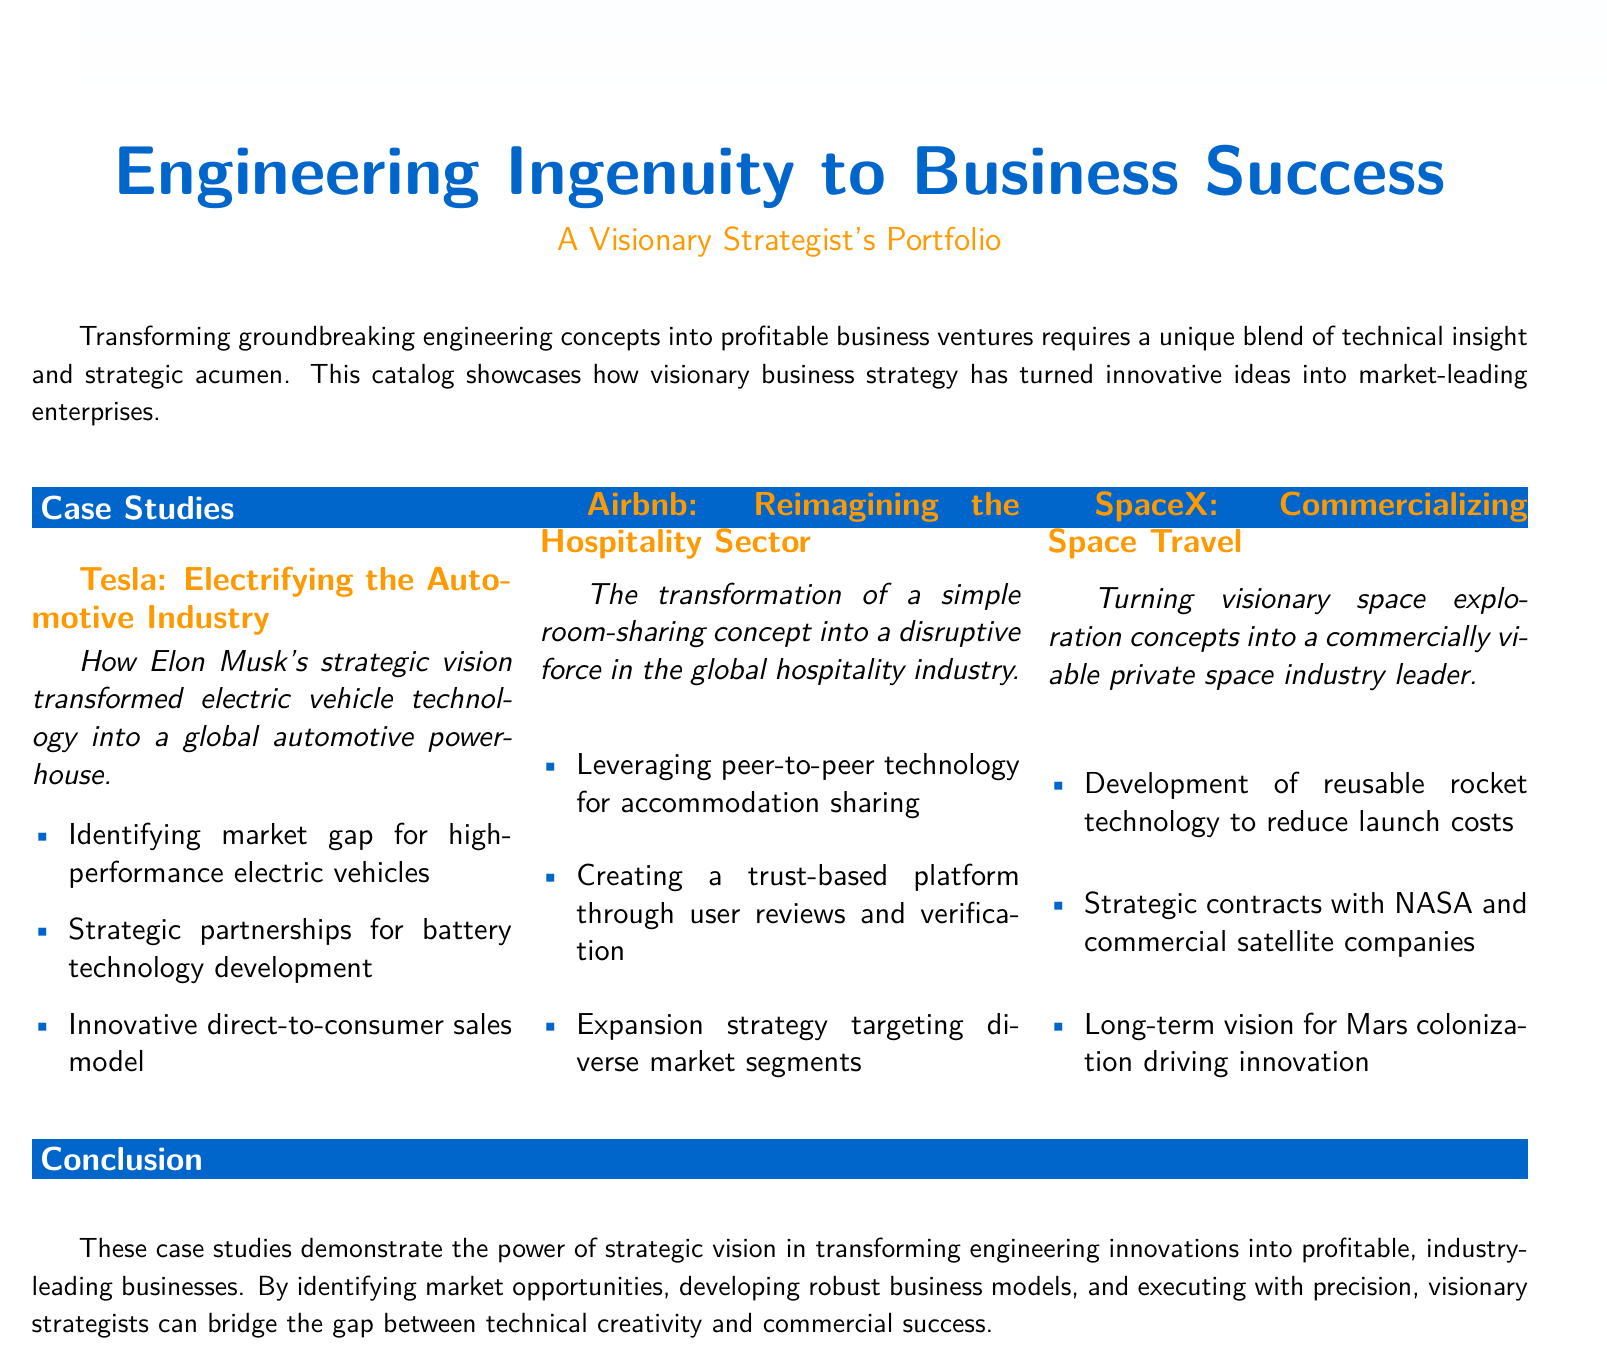What is the title of the catalog? The title of the catalog is prominently displayed at the top and summarizes the content, which is "Engineering Ingenuity to Business Success."
Answer: Engineering Ingenuity to Business Success Who is the visionary behind Tesla's transformation? The document mentions Elon Musk as the key visionary behind the transformation of Tesla.
Answer: Elon Musk How many case studies are showcased in the document? The catalog features a total of three case studies, each representing a different company.
Answer: 3 What is the primary innovation of SpaceX mentioned? The document states that the development of reusable rocket technology is SpaceX's primary innovation discussed in the case study.
Answer: Reusable rocket technology Which company disrupted the global hospitality industry? The document identifies Airbnb as the company that transformed the hospitality sector.
Answer: Airbnb What was a key strategy for Airbnb? A significant strategy employed by Airbnb involved leveraging peer-to-peer technology for accommodation sharing.
Answer: Peer-to-peer technology What is one long-term vision of SpaceX? The document states that a long-term vision for Mars colonization drives innovation at SpaceX.
Answer: Mars colonization Which color represents the main theme in the document? The main color used throughout the document is indicated to be blue, specifically RGB(0,102,204).
Answer: Blue 